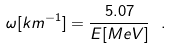<formula> <loc_0><loc_0><loc_500><loc_500>\omega [ k m ^ { - 1 } ] = \frac { 5 . 0 7 } { E [ M e V ] } \ .</formula> 